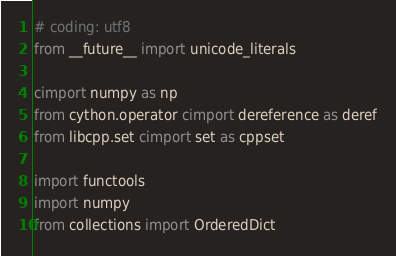<code> <loc_0><loc_0><loc_500><loc_500><_Cython_># coding: utf8
from __future__ import unicode_literals

cimport numpy as np
from cython.operator cimport dereference as deref
from libcpp.set cimport set as cppset

import functools
import numpy
from collections import OrderedDict</code> 